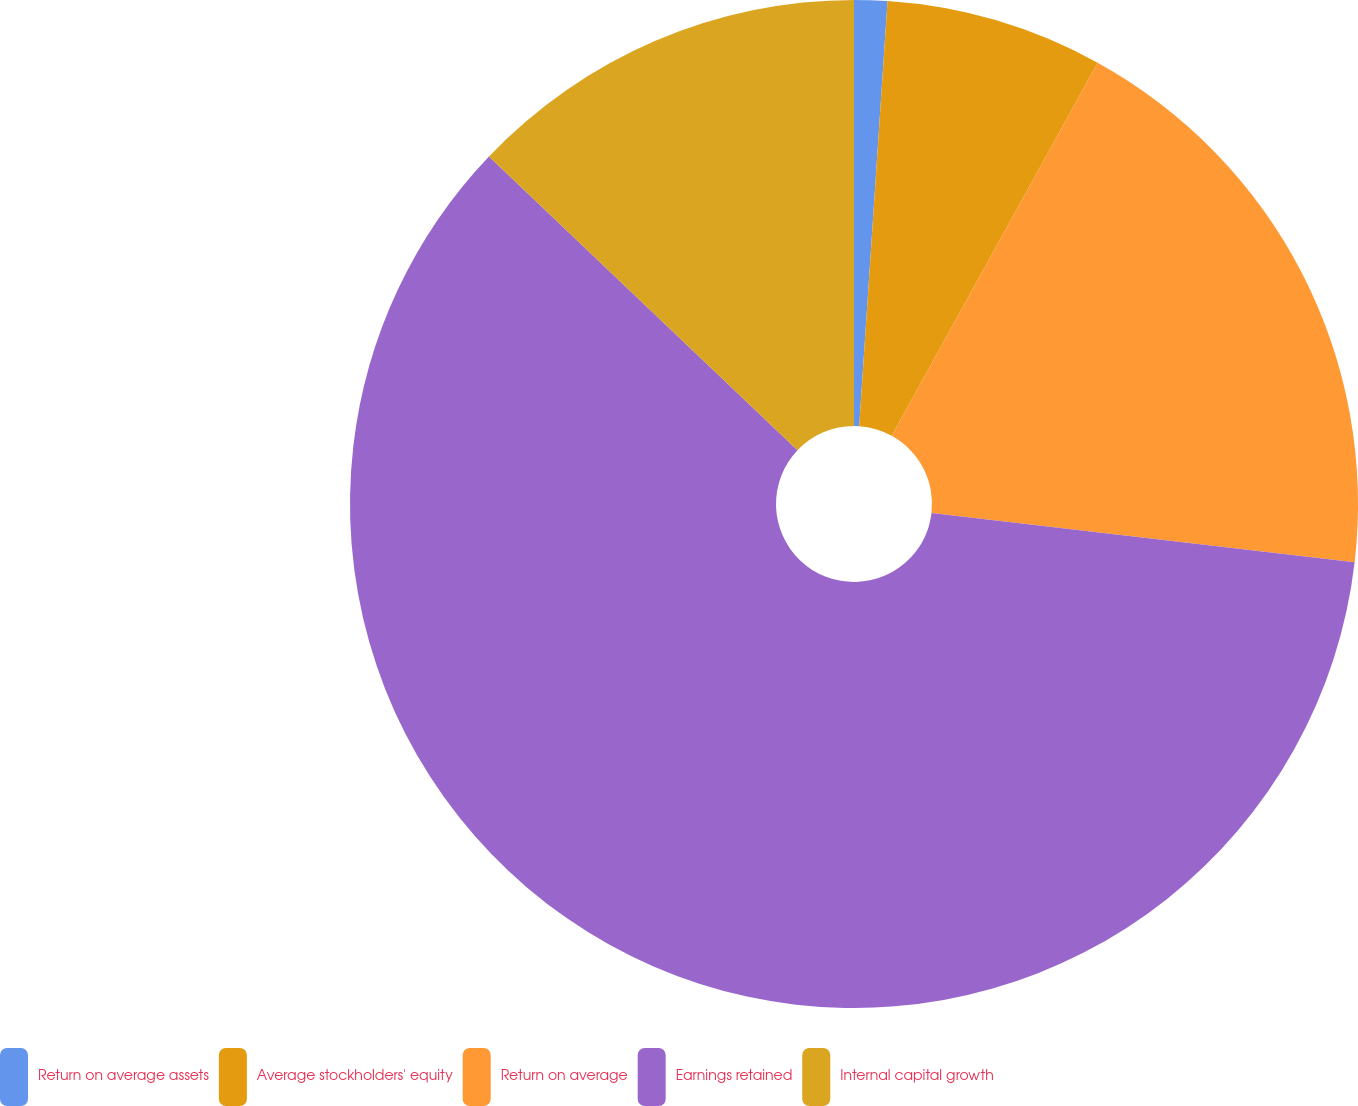Convert chart to OTSL. <chart><loc_0><loc_0><loc_500><loc_500><pie_chart><fcel>Return on average assets<fcel>Average stockholders' equity<fcel>Return on average<fcel>Earnings retained<fcel>Internal capital growth<nl><fcel>1.06%<fcel>6.97%<fcel>18.81%<fcel>60.26%<fcel>12.89%<nl></chart> 